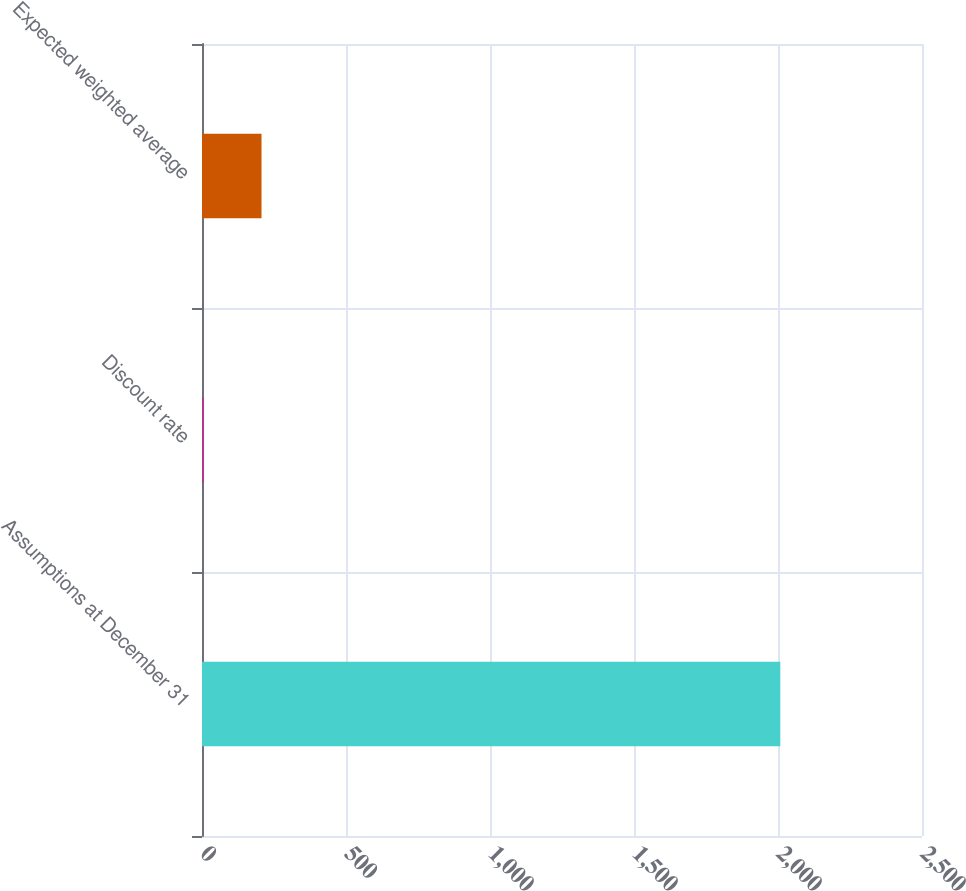<chart> <loc_0><loc_0><loc_500><loc_500><bar_chart><fcel>Assumptions at December 31<fcel>Discount rate<fcel>Expected weighted average<nl><fcel>2008<fcel>6.48<fcel>206.63<nl></chart> 